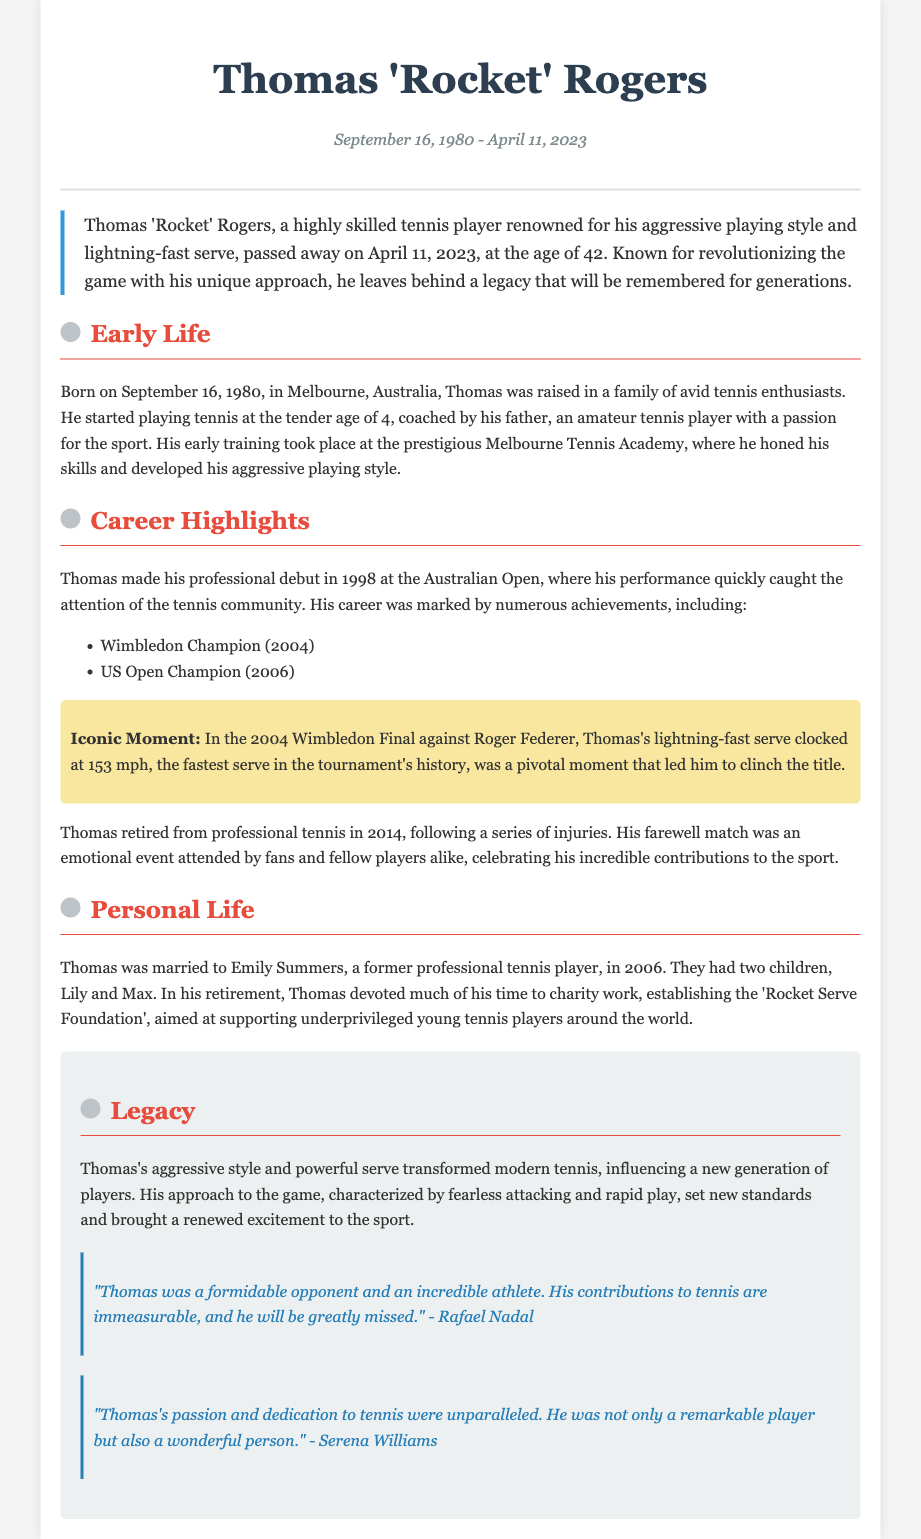What was Thomas's nickname? The document states that Thomas was known as 'Rocket'.
Answer: Rocket When was Thomas born? The document mentions that Thomas was born on September 16, 1980.
Answer: September 16, 1980 What was the fastest serve recorded by Thomas? The document provides that his lightning-fast serve clocked at 153 mph.
Answer: 153 mph Who was Thomas's spouse? The document indicates that Thomas was married to Emily Summers.
Answer: Emily Summers What foundation did Thomas establish? The document states that Thomas established the 'Rocket Serve Foundation'.
Answer: Rocket Serve Foundation In what year did Thomas retire? The document notes that Thomas retired from professional tennis in 2014.
Answer: 2014 Which Grand Slam did Thomas win in 2004? The document mentions that Thomas was a Wimbledon Champion in 2004.
Answer: Wimbledon What was significant about Thomas's playing style? The document describes his playing style as aggressive and characterized by fearless attacking and rapid play.
Answer: Aggressive Who quoted about Thomas's immeasurable contributions to tennis? The document includes a quote from Rafael Nadal regarding Thomas's contributions.
Answer: Rafael Nadal 